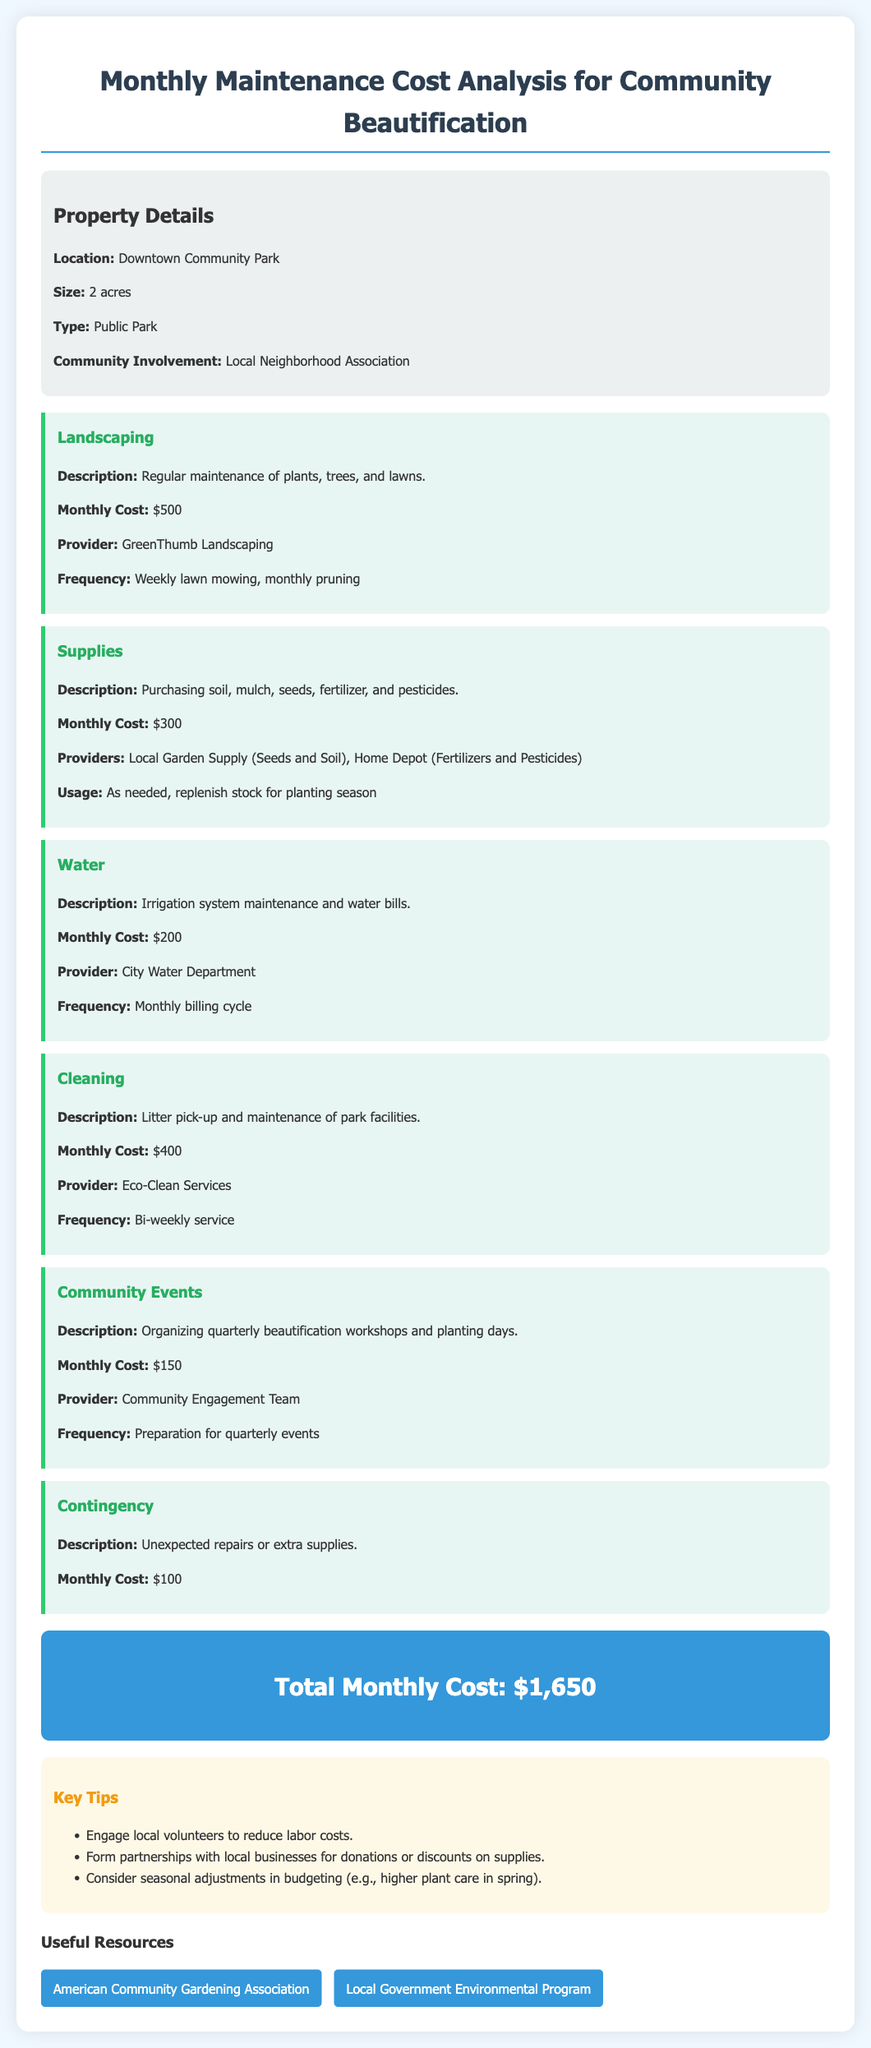What is the location of the property? The document specifies that the property is located in Downtown Community Park.
Answer: Downtown Community Park What is the size of the property? The property size is stated as 2 acres.
Answer: 2 acres What is the monthly cost for landscaping? The document provides the monthly cost for landscaping as $500.
Answer: $500 Who provides the water service? The water service is provided by the City Water Department, as mentioned in the cost category for water.
Answer: City Water Department What is the total monthly cost for community beautification initiatives? The total monthly cost is summarized at the end of the document as $1,650.
Answer: $1,650 How often is litter pick-up scheduled? The cleaning service frequency is described as bi-weekly in the document.
Answer: Bi-weekly What is one key tip for reducing labor costs? Engage local volunteers is highlighted as a key tip for reducing costs.
Answer: Engage local volunteers What supplies are included in the monthly supplies cost? The supplies category mentions soil, mulch, seeds, fertilizer, and pesticides.
Answer: Soil, mulch, seeds, fertilizer, pesticides How frequently are the community events organized? The community events are organized on a quarterly basis, as specified in the description.
Answer: Quarterly 